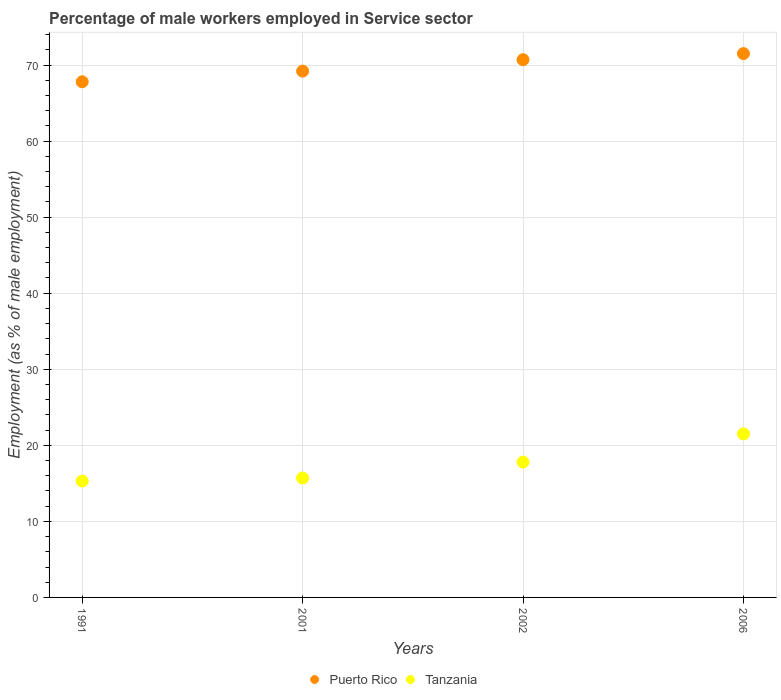What is the percentage of male workers employed in Service sector in Tanzania in 2001?
Offer a terse response. 15.7. Across all years, what is the minimum percentage of male workers employed in Service sector in Tanzania?
Your answer should be very brief. 15.3. In which year was the percentage of male workers employed in Service sector in Puerto Rico minimum?
Give a very brief answer. 1991. What is the total percentage of male workers employed in Service sector in Puerto Rico in the graph?
Give a very brief answer. 279.2. What is the difference between the percentage of male workers employed in Service sector in Puerto Rico in 2002 and that in 2006?
Offer a very short reply. -0.8. What is the difference between the percentage of male workers employed in Service sector in Puerto Rico in 1991 and the percentage of male workers employed in Service sector in Tanzania in 2001?
Give a very brief answer. 52.1. What is the average percentage of male workers employed in Service sector in Tanzania per year?
Your answer should be very brief. 17.57. In the year 2002, what is the difference between the percentage of male workers employed in Service sector in Tanzania and percentage of male workers employed in Service sector in Puerto Rico?
Offer a terse response. -52.9. What is the ratio of the percentage of male workers employed in Service sector in Puerto Rico in 2002 to that in 2006?
Provide a succinct answer. 0.99. Is the difference between the percentage of male workers employed in Service sector in Tanzania in 1991 and 2001 greater than the difference between the percentage of male workers employed in Service sector in Puerto Rico in 1991 and 2001?
Ensure brevity in your answer.  Yes. What is the difference between the highest and the second highest percentage of male workers employed in Service sector in Tanzania?
Your response must be concise. 3.7. What is the difference between the highest and the lowest percentage of male workers employed in Service sector in Puerto Rico?
Keep it short and to the point. 3.7. Is the sum of the percentage of male workers employed in Service sector in Tanzania in 1991 and 2002 greater than the maximum percentage of male workers employed in Service sector in Puerto Rico across all years?
Your response must be concise. No. How many years are there in the graph?
Ensure brevity in your answer.  4. Does the graph contain grids?
Make the answer very short. Yes. Where does the legend appear in the graph?
Your response must be concise. Bottom center. How many legend labels are there?
Provide a short and direct response. 2. What is the title of the graph?
Provide a short and direct response. Percentage of male workers employed in Service sector. Does "Myanmar" appear as one of the legend labels in the graph?
Your response must be concise. No. What is the label or title of the X-axis?
Offer a terse response. Years. What is the label or title of the Y-axis?
Provide a short and direct response. Employment (as % of male employment). What is the Employment (as % of male employment) of Puerto Rico in 1991?
Provide a succinct answer. 67.8. What is the Employment (as % of male employment) in Tanzania in 1991?
Offer a terse response. 15.3. What is the Employment (as % of male employment) of Puerto Rico in 2001?
Ensure brevity in your answer.  69.2. What is the Employment (as % of male employment) in Tanzania in 2001?
Offer a terse response. 15.7. What is the Employment (as % of male employment) in Puerto Rico in 2002?
Ensure brevity in your answer.  70.7. What is the Employment (as % of male employment) in Tanzania in 2002?
Give a very brief answer. 17.8. What is the Employment (as % of male employment) in Puerto Rico in 2006?
Provide a short and direct response. 71.5. Across all years, what is the maximum Employment (as % of male employment) in Puerto Rico?
Your answer should be very brief. 71.5. Across all years, what is the minimum Employment (as % of male employment) of Puerto Rico?
Offer a very short reply. 67.8. Across all years, what is the minimum Employment (as % of male employment) in Tanzania?
Provide a succinct answer. 15.3. What is the total Employment (as % of male employment) in Puerto Rico in the graph?
Your answer should be compact. 279.2. What is the total Employment (as % of male employment) of Tanzania in the graph?
Your answer should be very brief. 70.3. What is the difference between the Employment (as % of male employment) of Puerto Rico in 1991 and that in 2002?
Ensure brevity in your answer.  -2.9. What is the difference between the Employment (as % of male employment) of Tanzania in 1991 and that in 2002?
Ensure brevity in your answer.  -2.5. What is the difference between the Employment (as % of male employment) in Puerto Rico in 2001 and that in 2006?
Make the answer very short. -2.3. What is the difference between the Employment (as % of male employment) in Tanzania in 2001 and that in 2006?
Your answer should be very brief. -5.8. What is the difference between the Employment (as % of male employment) in Puerto Rico in 2002 and that in 2006?
Provide a short and direct response. -0.8. What is the difference between the Employment (as % of male employment) in Puerto Rico in 1991 and the Employment (as % of male employment) in Tanzania in 2001?
Your answer should be very brief. 52.1. What is the difference between the Employment (as % of male employment) in Puerto Rico in 1991 and the Employment (as % of male employment) in Tanzania in 2006?
Make the answer very short. 46.3. What is the difference between the Employment (as % of male employment) in Puerto Rico in 2001 and the Employment (as % of male employment) in Tanzania in 2002?
Offer a terse response. 51.4. What is the difference between the Employment (as % of male employment) of Puerto Rico in 2001 and the Employment (as % of male employment) of Tanzania in 2006?
Provide a short and direct response. 47.7. What is the difference between the Employment (as % of male employment) of Puerto Rico in 2002 and the Employment (as % of male employment) of Tanzania in 2006?
Your response must be concise. 49.2. What is the average Employment (as % of male employment) of Puerto Rico per year?
Provide a short and direct response. 69.8. What is the average Employment (as % of male employment) in Tanzania per year?
Provide a short and direct response. 17.57. In the year 1991, what is the difference between the Employment (as % of male employment) in Puerto Rico and Employment (as % of male employment) in Tanzania?
Offer a terse response. 52.5. In the year 2001, what is the difference between the Employment (as % of male employment) of Puerto Rico and Employment (as % of male employment) of Tanzania?
Offer a terse response. 53.5. In the year 2002, what is the difference between the Employment (as % of male employment) of Puerto Rico and Employment (as % of male employment) of Tanzania?
Keep it short and to the point. 52.9. What is the ratio of the Employment (as % of male employment) of Puerto Rico in 1991 to that in 2001?
Make the answer very short. 0.98. What is the ratio of the Employment (as % of male employment) of Tanzania in 1991 to that in 2001?
Your answer should be very brief. 0.97. What is the ratio of the Employment (as % of male employment) of Tanzania in 1991 to that in 2002?
Provide a short and direct response. 0.86. What is the ratio of the Employment (as % of male employment) in Puerto Rico in 1991 to that in 2006?
Your response must be concise. 0.95. What is the ratio of the Employment (as % of male employment) of Tanzania in 1991 to that in 2006?
Provide a succinct answer. 0.71. What is the ratio of the Employment (as % of male employment) in Puerto Rico in 2001 to that in 2002?
Offer a terse response. 0.98. What is the ratio of the Employment (as % of male employment) in Tanzania in 2001 to that in 2002?
Your response must be concise. 0.88. What is the ratio of the Employment (as % of male employment) of Puerto Rico in 2001 to that in 2006?
Keep it short and to the point. 0.97. What is the ratio of the Employment (as % of male employment) of Tanzania in 2001 to that in 2006?
Make the answer very short. 0.73. What is the ratio of the Employment (as % of male employment) in Puerto Rico in 2002 to that in 2006?
Provide a short and direct response. 0.99. What is the ratio of the Employment (as % of male employment) of Tanzania in 2002 to that in 2006?
Provide a succinct answer. 0.83. What is the difference between the highest and the lowest Employment (as % of male employment) in Puerto Rico?
Give a very brief answer. 3.7. 